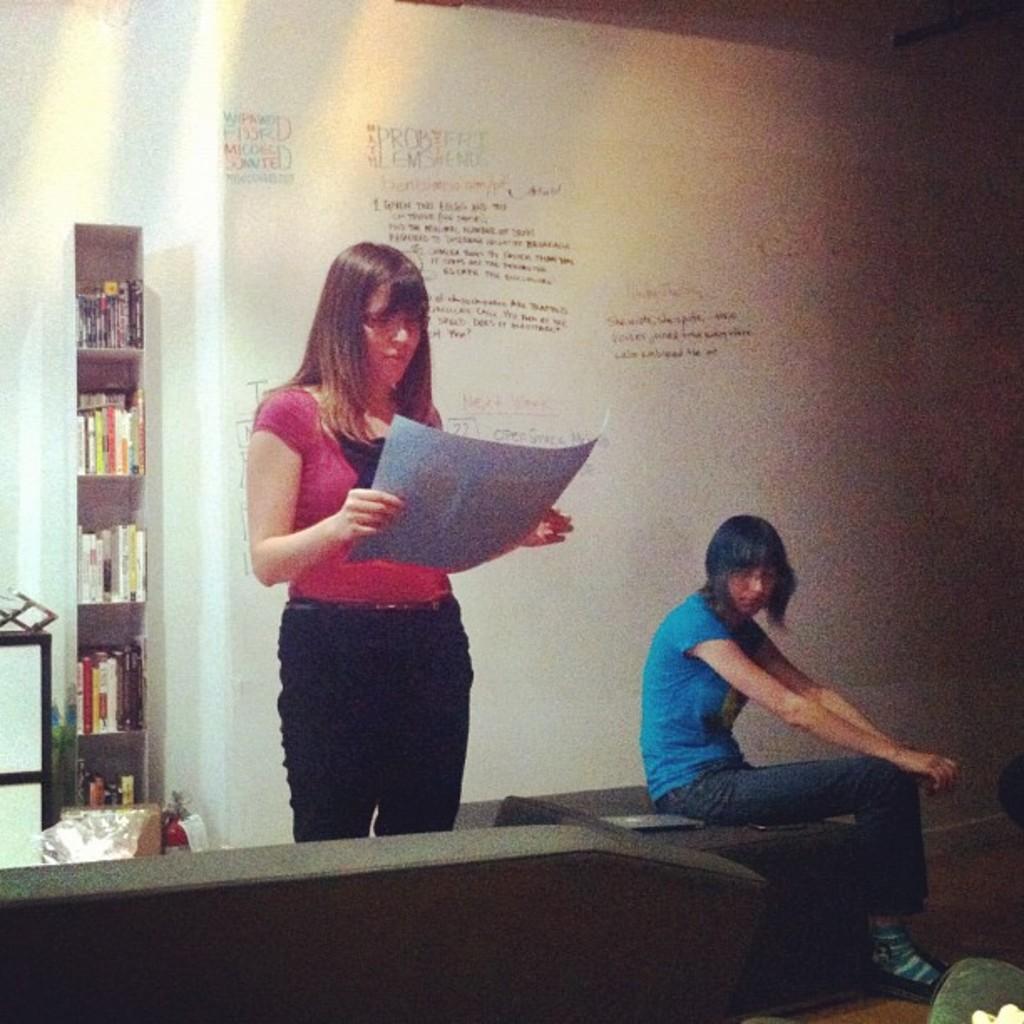Could you give a brief overview of what you see in this image? In this picture we can see two women, one woman is holding paper, another woman is sitting on a couch, behind we can see bookshelves, we can see board to the wall. 